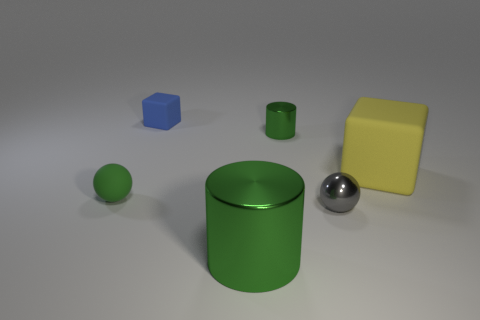Add 1 tiny green matte cylinders. How many objects exist? 7 Add 5 blue matte things. How many blue matte things are left? 6 Add 5 green metal things. How many green metal things exist? 7 Subtract 0 purple spheres. How many objects are left? 6 Subtract all large green metallic cylinders. Subtract all yellow rubber cubes. How many objects are left? 4 